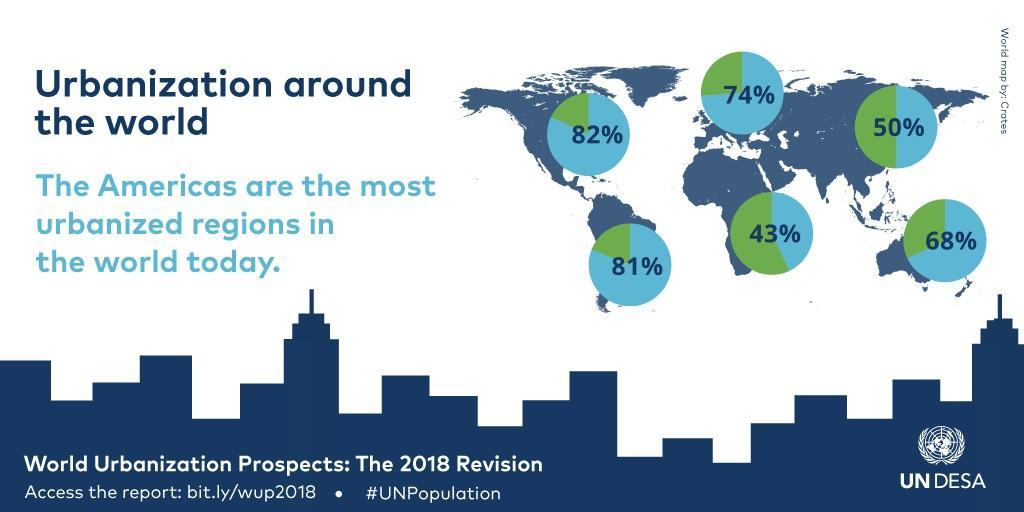What is the difference in percentage between North America and Australia?
Answer the question with a short phrase. 14% What is the difference in percentage between North America and South America? 1% 